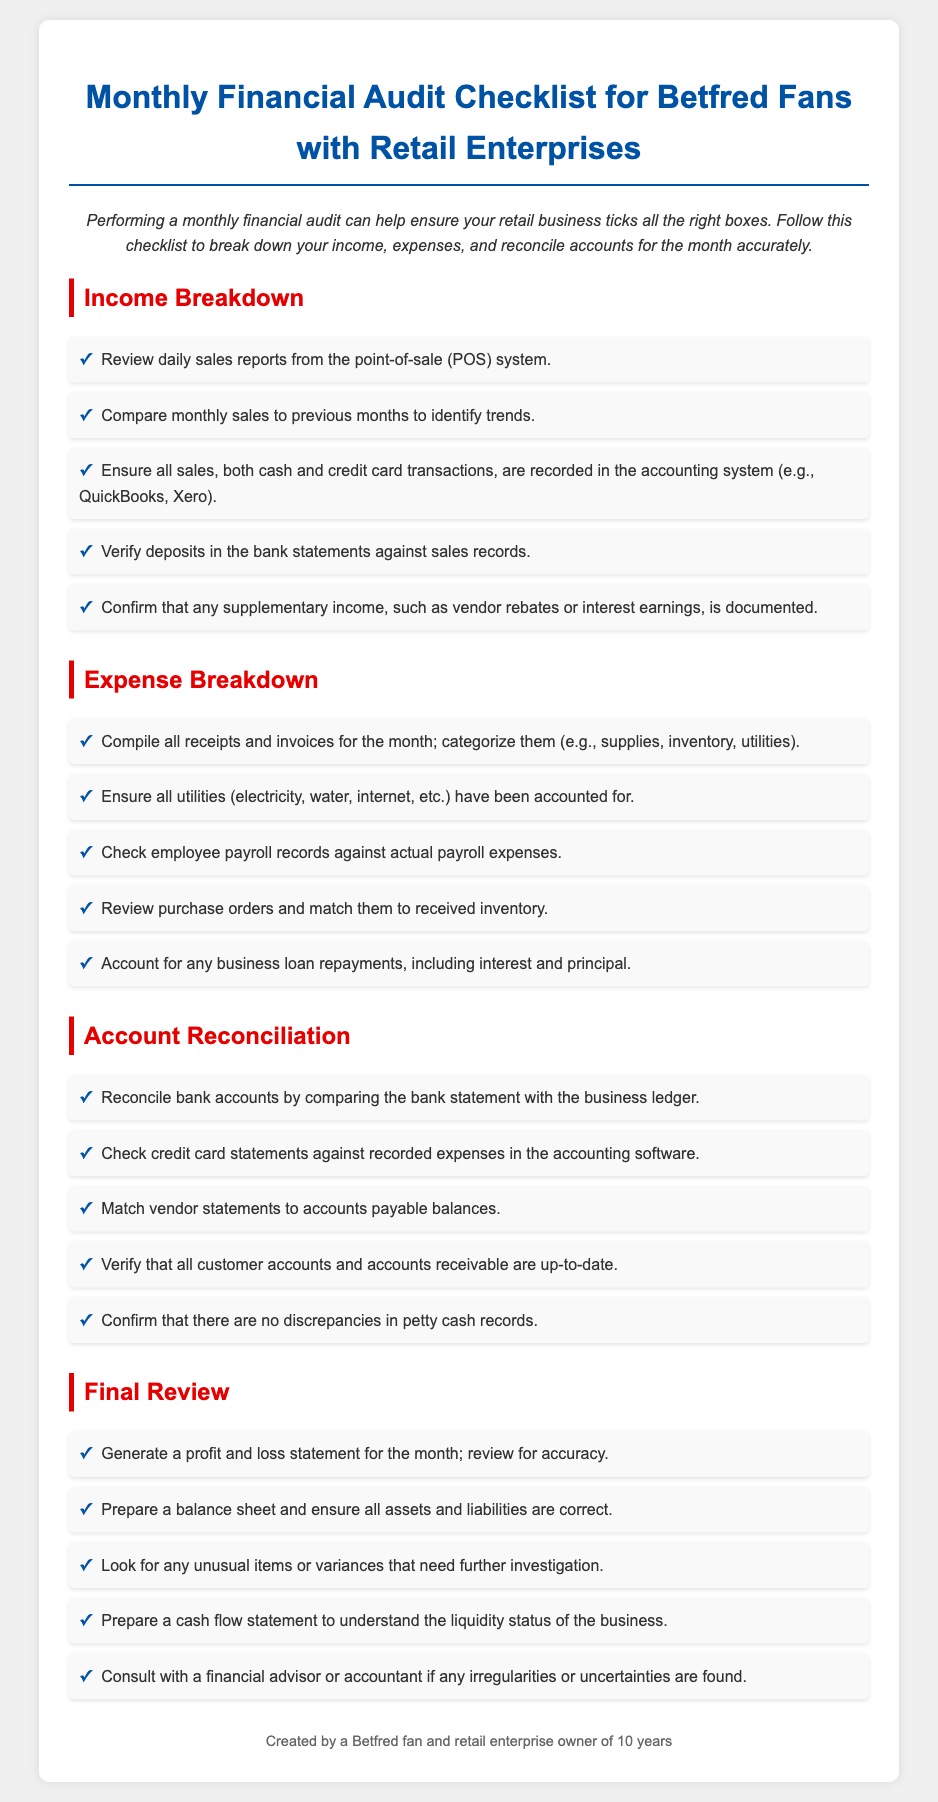what is the title of the document? The title of the document is displayed prominently at the top and provides a clear description of its purpose.
Answer: Monthly Financial Audit Checklist for Betfred Fans with Retail Enterprises how many sections are in the checklist? The document is divided into four main sections that outline different aspects of the financial audit process.
Answer: Four what is the first item listed under Income Breakdown? The first item under the Income Breakdown section mentions reviewing sales reports, indicating the starting point of income analysis.
Answer: Review daily sales reports from the point-of-sale (POS) system which category includes checking employee payroll records? Employee payroll records are categorized under the Expense Breakdown section, relating to expense verification.
Answer: Expense Breakdown what is the purpose of generating a profit and loss statement? The profit and loss statement is generated as part of the final review to ensure financial accuracy for the month.
Answer: Review for accuracy in which section would you find information about matching vendor statements? Vendor statements matching is discussed in the Account Reconciliation section, emphasizing the need for accuracy in payables.
Answer: Account Reconciliation what document does the final review prepare to understand business liquidity? The final review includes preparing a specific type of financial statement that details liquidity.
Answer: Cash flow statement how should all sales transactions be recorded? The checklist specifies the requirement for recording both cash and credit card transactions in the accounting system.
Answer: In the accounting system 